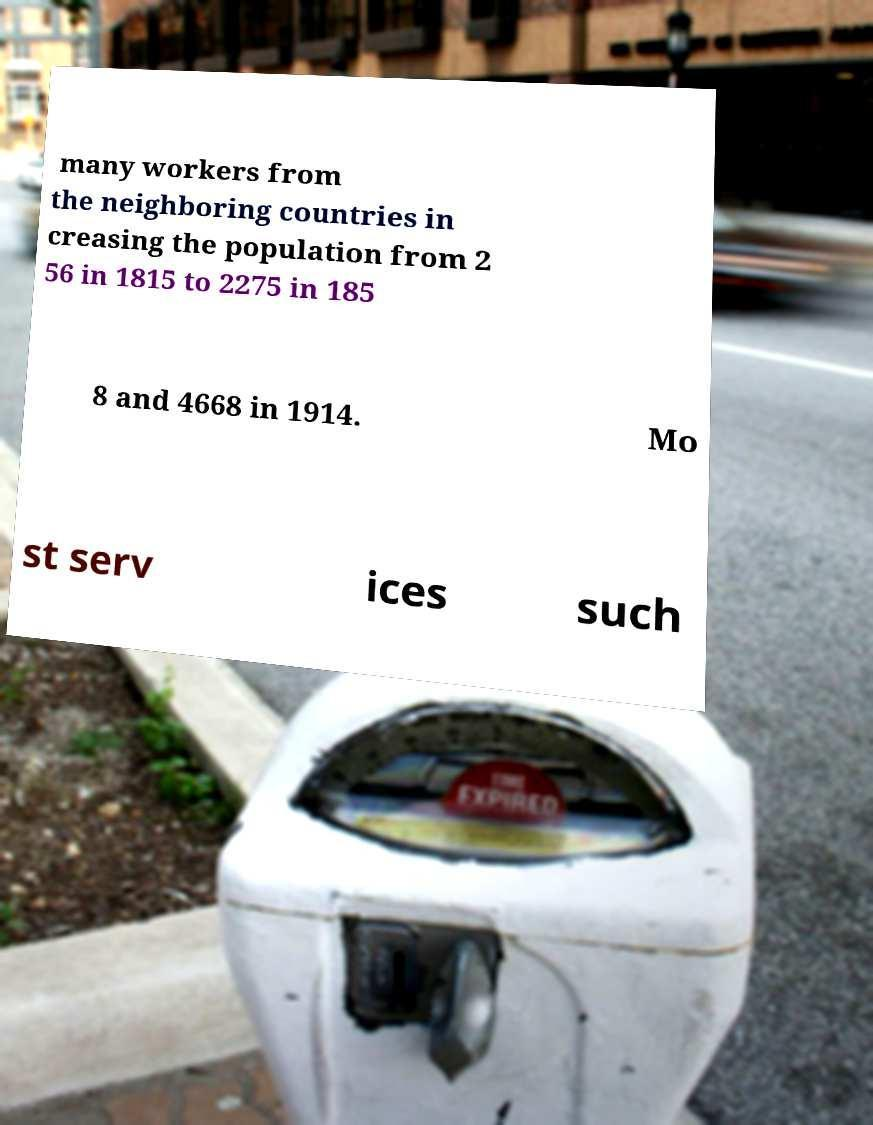Could you extract and type out the text from this image? many workers from the neighboring countries in creasing the population from 2 56 in 1815 to 2275 in 185 8 and 4668 in 1914. Mo st serv ices such 